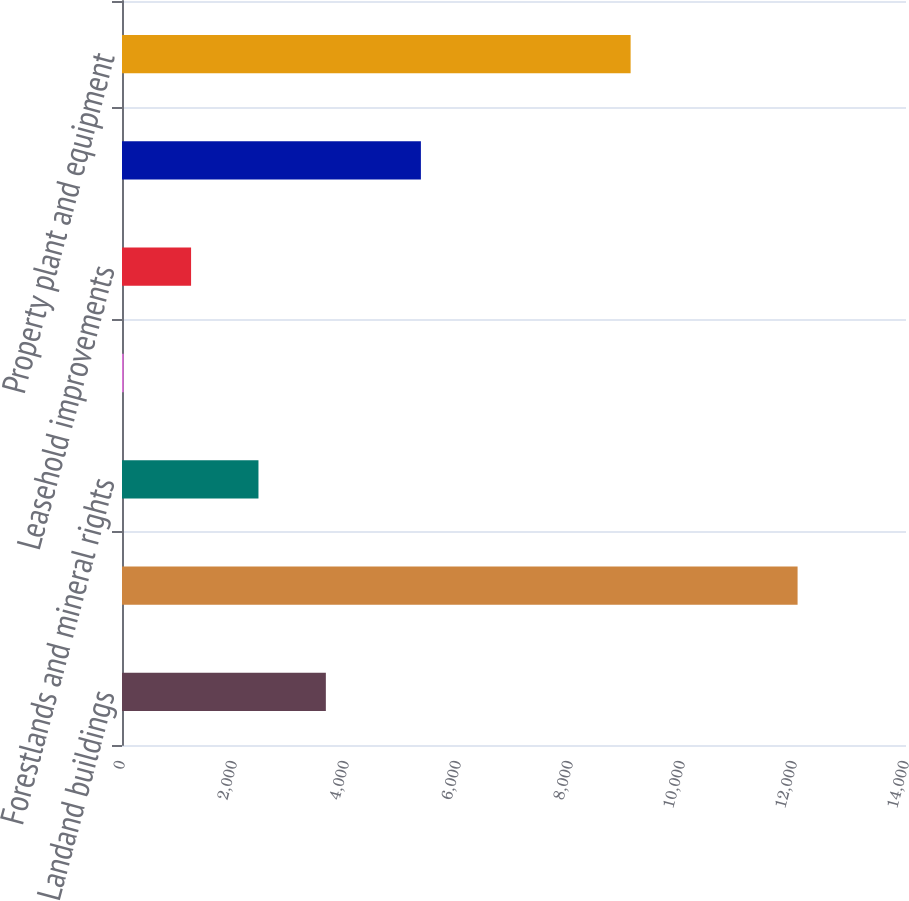Convert chart. <chart><loc_0><loc_0><loc_500><loc_500><bar_chart><fcel>Landand buildings<fcel>Machinery and equipment<fcel>Forestlands and mineral rights<fcel>Transportation equipment<fcel>Leasehold improvements<fcel>Less accumulated depreciation<fcel>Property plant and equipment<nl><fcel>3640.27<fcel>12064<fcel>2436.88<fcel>30.1<fcel>1233.49<fcel>5337.4<fcel>9082.5<nl></chart> 